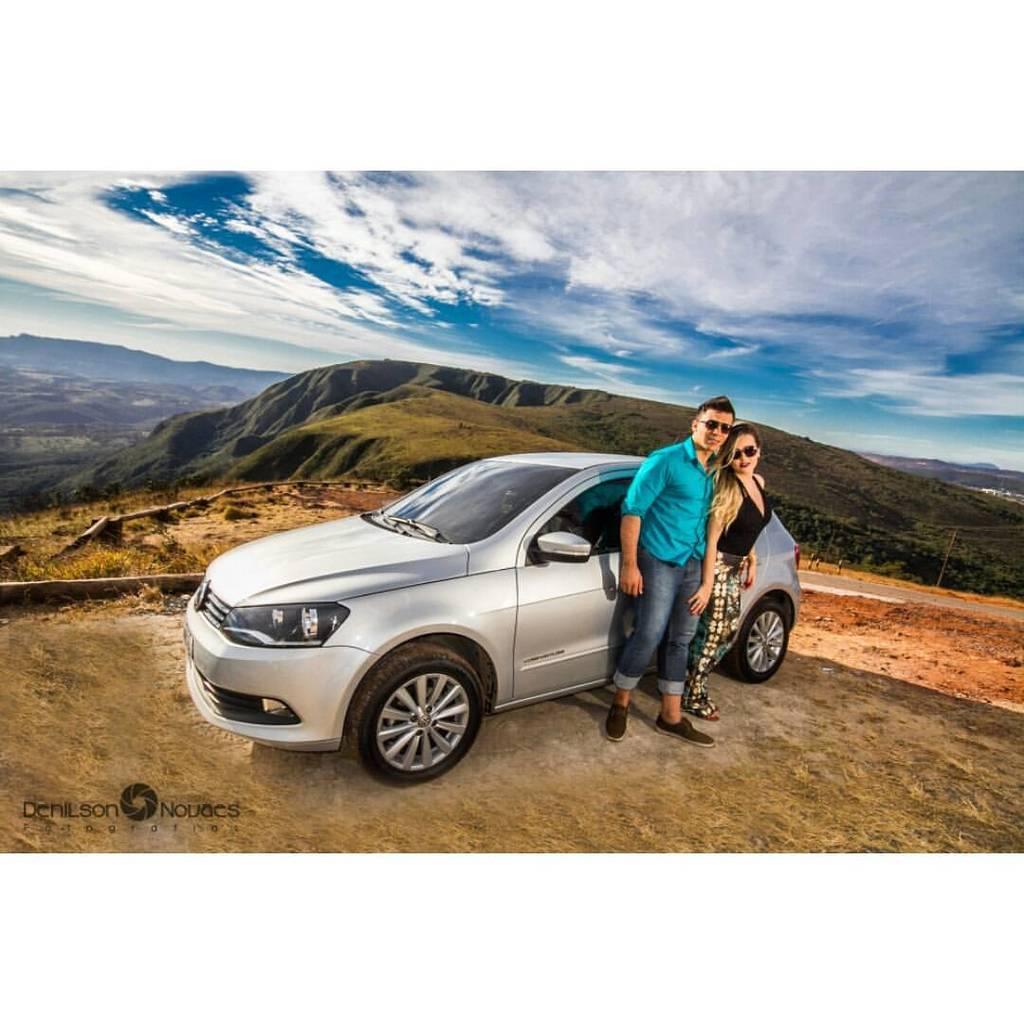Can you describe this image briefly? In the picture we can see a man and a woman standing near the car and the car is gray in color and in the background, we can see some grass plants and hills and sky with clouds. 